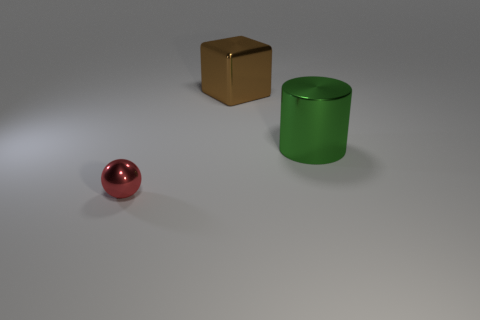There is a sphere; how many objects are to the right of it?
Make the answer very short. 2. There is a shiny thing that is to the right of the sphere and in front of the brown metallic thing; what size is it?
Your response must be concise. Large. What number of brown objects are large metal cylinders or metallic blocks?
Keep it short and to the point. 1. What is the shape of the large brown object?
Provide a succinct answer. Cube. How many other objects are the same shape as the big green metal object?
Offer a terse response. 0. There is a big thing that is to the left of the big green metal cylinder; what is its color?
Your answer should be compact. Brown. How many things are either cyan rubber things or things that are behind the green shiny thing?
Provide a short and direct response. 1. There is a large thing on the right side of the cube; what shape is it?
Your response must be concise. Cylinder. Do the shiny object that is in front of the cylinder and the large shiny block have the same size?
Ensure brevity in your answer.  No. Is there another small metal sphere of the same color as the tiny sphere?
Your answer should be compact. No. 